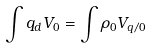<formula> <loc_0><loc_0><loc_500><loc_500>\int q _ { d } V _ { 0 } = \int \rho _ { 0 } V _ { q / 0 }</formula> 